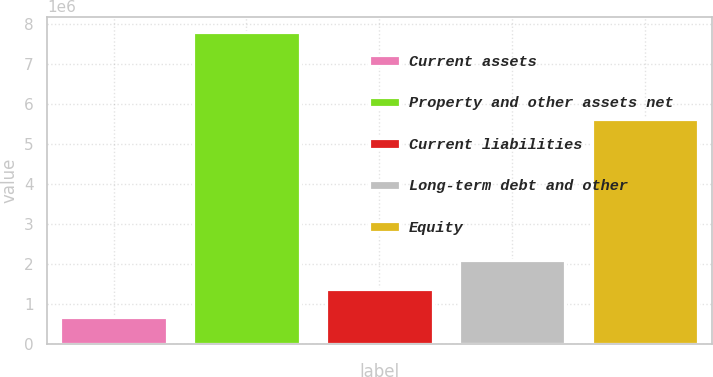<chart> <loc_0><loc_0><loc_500><loc_500><bar_chart><fcel>Current assets<fcel>Property and other assets net<fcel>Current liabilities<fcel>Long-term debt and other<fcel>Equity<nl><fcel>676746<fcel>7.79734e+06<fcel>1.38881e+06<fcel>2.10087e+06<fcel>5.64125e+06<nl></chart> 